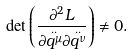<formula> <loc_0><loc_0><loc_500><loc_500>\det \left ( \frac { \partial ^ { 2 } L } { \partial \overset { . . } { q ^ { \mu } } \partial \overset { . . } { q ^ { \nu } } } \right ) \neq 0 .</formula> 